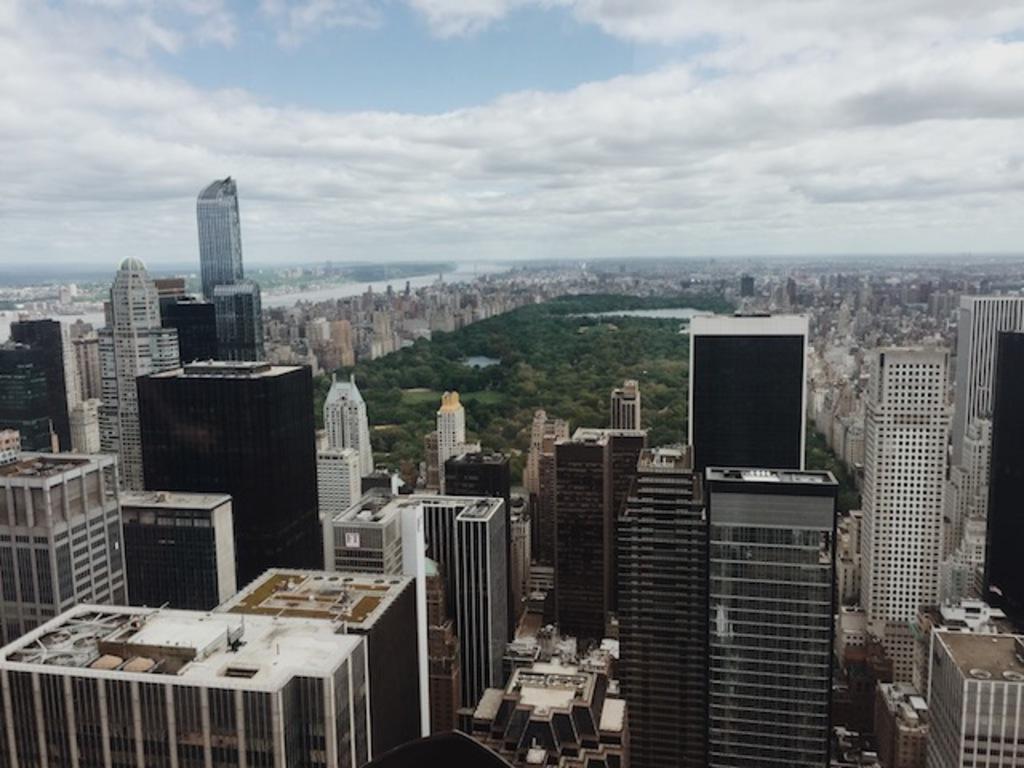Describe this image in one or two sentences. This is an aerial view image of a city, there are skyscrapers all over the place with a park in the middle and above its sky with clouds. 